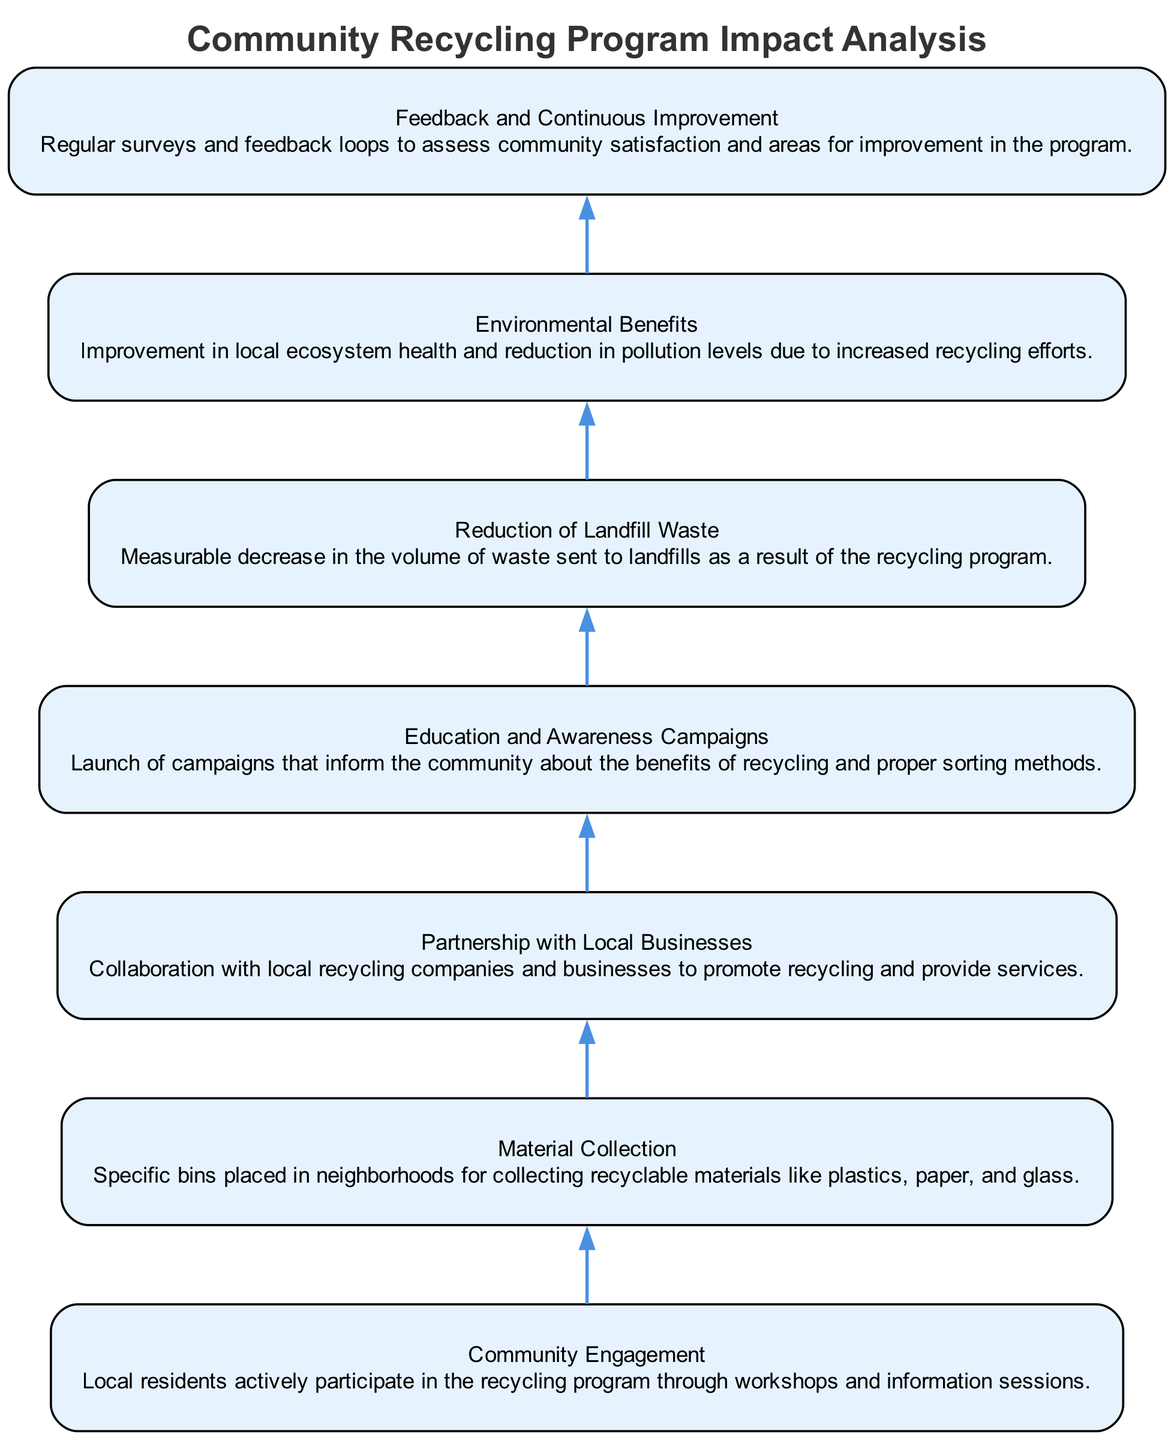What is the first element in the diagram? The first element in the diagram is "Community Engagement," which represents the initial step of involving local residents in the recycling program.
Answer: Community Engagement How many elements are there in total? By counting the items listed in the diagram, there are 7 elements representing different aspects of the community recycling program.
Answer: 7 What is the last element connected to in the flow? The last element, "Feedback and Continuous Improvement," is connected to "Environmental Benefits," emphasizing the cyclical nature of the program where feedback leads to enhanced environmental outcomes.
Answer: Environmental Benefits Which element emphasizes the importance of local businesses? The element titled "Partnership with Local Businesses" focuses on the role of local businesses in supporting the recycling initiative through collaboration and service provision.
Answer: Partnership with Local Businesses What impact is measured directly from the recycling program? The "Reduction of Landfill Waste" is a measurable impact that indicates the effectiveness of the recycling program in decreasing the volume of waste sent to landfills.
Answer: Reduction of Landfill Waste How is community satisfaction assessed in the diagram? Community satisfaction is assessed through the "Feedback and Continuous Improvement" element, which involves regular surveys and feedback mechanisms to identify areas for enhancement in the recycling program.
Answer: Feedback and Continuous Improvement What is the main purpose of the "Education and Awareness Campaigns" element? The main purpose of the "Education and Awareness Campaigns" is to inform the community about recycling benefits and proper sorting methods to enhance overall participation and effectiveness of the program.
Answer: Education and Awareness Campaigns Which two elements are interconnected in the flow chart that suggest a cause-and-effect relationship? "Material Collection" leads to "Reduction of Landfill Waste," indicating that effective collection of recyclables has a direct positive effect by lowering the amount of waste that goes into landfills.
Answer: Material Collection and Reduction of Landfill Waste 